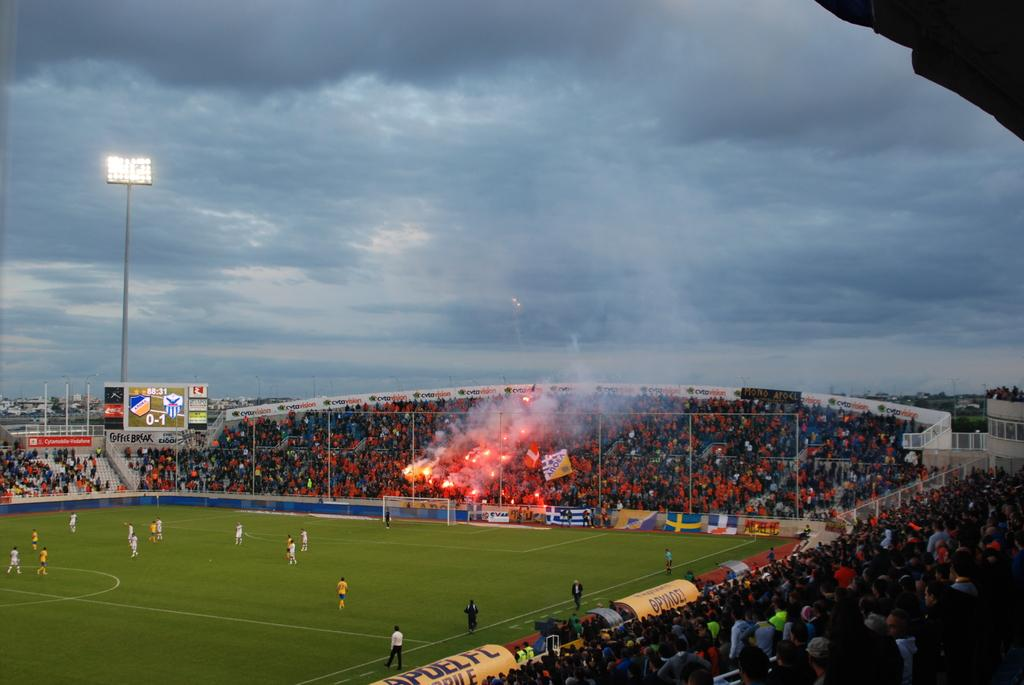<image>
Summarize the visual content of the image. A soccer field with a coffee break advertisement under the score board 